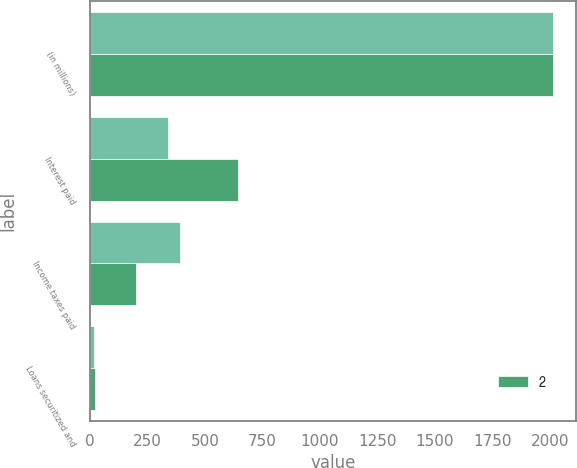<chart> <loc_0><loc_0><loc_500><loc_500><stacked_bar_chart><ecel><fcel>(in millions)<fcel>Interest paid<fcel>Income taxes paid<fcel>Loans securitized and<nl><fcel>nan<fcel>2014<fcel>338<fcel>391<fcel>18<nl><fcel>2<fcel>2012<fcel>644<fcel>201<fcel>21<nl></chart> 